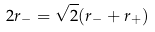<formula> <loc_0><loc_0><loc_500><loc_500>2 r _ { - } = \sqrt { 2 } ( r _ { - } + r _ { + } )</formula> 